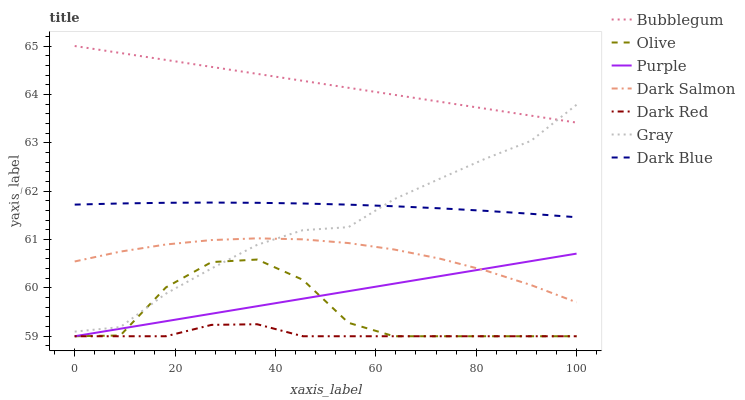Does Dark Red have the minimum area under the curve?
Answer yes or no. Yes. Does Bubblegum have the maximum area under the curve?
Answer yes or no. Yes. Does Purple have the minimum area under the curve?
Answer yes or no. No. Does Purple have the maximum area under the curve?
Answer yes or no. No. Is Purple the smoothest?
Answer yes or no. Yes. Is Olive the roughest?
Answer yes or no. Yes. Is Dark Red the smoothest?
Answer yes or no. No. Is Dark Red the roughest?
Answer yes or no. No. Does Purple have the lowest value?
Answer yes or no. Yes. Does Dark Salmon have the lowest value?
Answer yes or no. No. Does Bubblegum have the highest value?
Answer yes or no. Yes. Does Purple have the highest value?
Answer yes or no. No. Is Dark Salmon less than Dark Blue?
Answer yes or no. Yes. Is Bubblegum greater than Dark Blue?
Answer yes or no. Yes. Does Purple intersect Olive?
Answer yes or no. Yes. Is Purple less than Olive?
Answer yes or no. No. Is Purple greater than Olive?
Answer yes or no. No. Does Dark Salmon intersect Dark Blue?
Answer yes or no. No. 